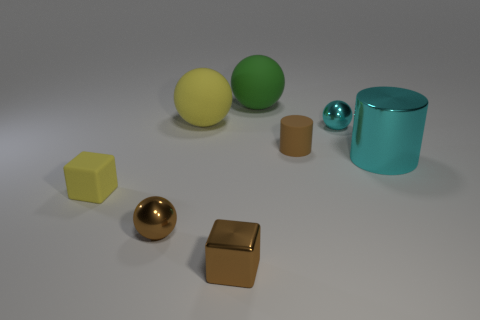Are there any tiny spheres left of the big yellow matte ball? Yes, to the left of the large yellow matte sphere, there is one small blue metallic sphere. 